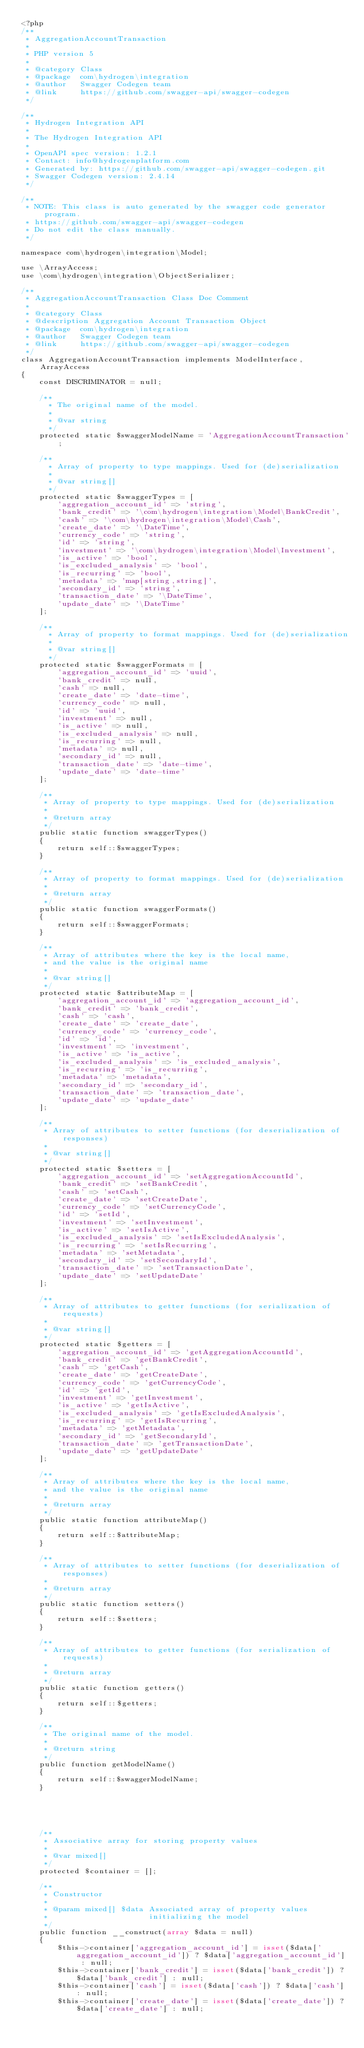<code> <loc_0><loc_0><loc_500><loc_500><_PHP_><?php
/**
 * AggregationAccountTransaction
 *
 * PHP version 5
 *
 * @category Class
 * @package  com\hydrogen\integration
 * @author   Swagger Codegen team
 * @link     https://github.com/swagger-api/swagger-codegen
 */

/**
 * Hydrogen Integration API
 *
 * The Hydrogen Integration API
 *
 * OpenAPI spec version: 1.2.1
 * Contact: info@hydrogenplatform.com
 * Generated by: https://github.com/swagger-api/swagger-codegen.git
 * Swagger Codegen version: 2.4.14
 */

/**
 * NOTE: This class is auto generated by the swagger code generator program.
 * https://github.com/swagger-api/swagger-codegen
 * Do not edit the class manually.
 */

namespace com\hydrogen\integration\Model;

use \ArrayAccess;
use \com\hydrogen\integration\ObjectSerializer;

/**
 * AggregationAccountTransaction Class Doc Comment
 *
 * @category Class
 * @description Aggregation Account Transaction Object
 * @package  com\hydrogen\integration
 * @author   Swagger Codegen team
 * @link     https://github.com/swagger-api/swagger-codegen
 */
class AggregationAccountTransaction implements ModelInterface, ArrayAccess
{
    const DISCRIMINATOR = null;

    /**
      * The original name of the model.
      *
      * @var string
      */
    protected static $swaggerModelName = 'AggregationAccountTransaction';

    /**
      * Array of property to type mappings. Used for (de)serialization
      *
      * @var string[]
      */
    protected static $swaggerTypes = [
        'aggregation_account_id' => 'string',
        'bank_credit' => '\com\hydrogen\integration\Model\BankCredit',
        'cash' => '\com\hydrogen\integration\Model\Cash',
        'create_date' => '\DateTime',
        'currency_code' => 'string',
        'id' => 'string',
        'investment' => '\com\hydrogen\integration\Model\Investment',
        'is_active' => 'bool',
        'is_excluded_analysis' => 'bool',
        'is_recurring' => 'bool',
        'metadata' => 'map[string,string]',
        'secondary_id' => 'string',
        'transaction_date' => '\DateTime',
        'update_date' => '\DateTime'
    ];

    /**
      * Array of property to format mappings. Used for (de)serialization
      *
      * @var string[]
      */
    protected static $swaggerFormats = [
        'aggregation_account_id' => 'uuid',
        'bank_credit' => null,
        'cash' => null,
        'create_date' => 'date-time',
        'currency_code' => null,
        'id' => 'uuid',
        'investment' => null,
        'is_active' => null,
        'is_excluded_analysis' => null,
        'is_recurring' => null,
        'metadata' => null,
        'secondary_id' => null,
        'transaction_date' => 'date-time',
        'update_date' => 'date-time'
    ];

    /**
     * Array of property to type mappings. Used for (de)serialization
     *
     * @return array
     */
    public static function swaggerTypes()
    {
        return self::$swaggerTypes;
    }

    /**
     * Array of property to format mappings. Used for (de)serialization
     *
     * @return array
     */
    public static function swaggerFormats()
    {
        return self::$swaggerFormats;
    }

    /**
     * Array of attributes where the key is the local name,
     * and the value is the original name
     *
     * @var string[]
     */
    protected static $attributeMap = [
        'aggregation_account_id' => 'aggregation_account_id',
        'bank_credit' => 'bank_credit',
        'cash' => 'cash',
        'create_date' => 'create_date',
        'currency_code' => 'currency_code',
        'id' => 'id',
        'investment' => 'investment',
        'is_active' => 'is_active',
        'is_excluded_analysis' => 'is_excluded_analysis',
        'is_recurring' => 'is_recurring',
        'metadata' => 'metadata',
        'secondary_id' => 'secondary_id',
        'transaction_date' => 'transaction_date',
        'update_date' => 'update_date'
    ];

    /**
     * Array of attributes to setter functions (for deserialization of responses)
     *
     * @var string[]
     */
    protected static $setters = [
        'aggregation_account_id' => 'setAggregationAccountId',
        'bank_credit' => 'setBankCredit',
        'cash' => 'setCash',
        'create_date' => 'setCreateDate',
        'currency_code' => 'setCurrencyCode',
        'id' => 'setId',
        'investment' => 'setInvestment',
        'is_active' => 'setIsActive',
        'is_excluded_analysis' => 'setIsExcludedAnalysis',
        'is_recurring' => 'setIsRecurring',
        'metadata' => 'setMetadata',
        'secondary_id' => 'setSecondaryId',
        'transaction_date' => 'setTransactionDate',
        'update_date' => 'setUpdateDate'
    ];

    /**
     * Array of attributes to getter functions (for serialization of requests)
     *
     * @var string[]
     */
    protected static $getters = [
        'aggregation_account_id' => 'getAggregationAccountId',
        'bank_credit' => 'getBankCredit',
        'cash' => 'getCash',
        'create_date' => 'getCreateDate',
        'currency_code' => 'getCurrencyCode',
        'id' => 'getId',
        'investment' => 'getInvestment',
        'is_active' => 'getIsActive',
        'is_excluded_analysis' => 'getIsExcludedAnalysis',
        'is_recurring' => 'getIsRecurring',
        'metadata' => 'getMetadata',
        'secondary_id' => 'getSecondaryId',
        'transaction_date' => 'getTransactionDate',
        'update_date' => 'getUpdateDate'
    ];

    /**
     * Array of attributes where the key is the local name,
     * and the value is the original name
     *
     * @return array
     */
    public static function attributeMap()
    {
        return self::$attributeMap;
    }

    /**
     * Array of attributes to setter functions (for deserialization of responses)
     *
     * @return array
     */
    public static function setters()
    {
        return self::$setters;
    }

    /**
     * Array of attributes to getter functions (for serialization of requests)
     *
     * @return array
     */
    public static function getters()
    {
        return self::$getters;
    }

    /**
     * The original name of the model.
     *
     * @return string
     */
    public function getModelName()
    {
        return self::$swaggerModelName;
    }

    

    

    /**
     * Associative array for storing property values
     *
     * @var mixed[]
     */
    protected $container = [];

    /**
     * Constructor
     *
     * @param mixed[] $data Associated array of property values
     *                      initializing the model
     */
    public function __construct(array $data = null)
    {
        $this->container['aggregation_account_id'] = isset($data['aggregation_account_id']) ? $data['aggregation_account_id'] : null;
        $this->container['bank_credit'] = isset($data['bank_credit']) ? $data['bank_credit'] : null;
        $this->container['cash'] = isset($data['cash']) ? $data['cash'] : null;
        $this->container['create_date'] = isset($data['create_date']) ? $data['create_date'] : null;</code> 